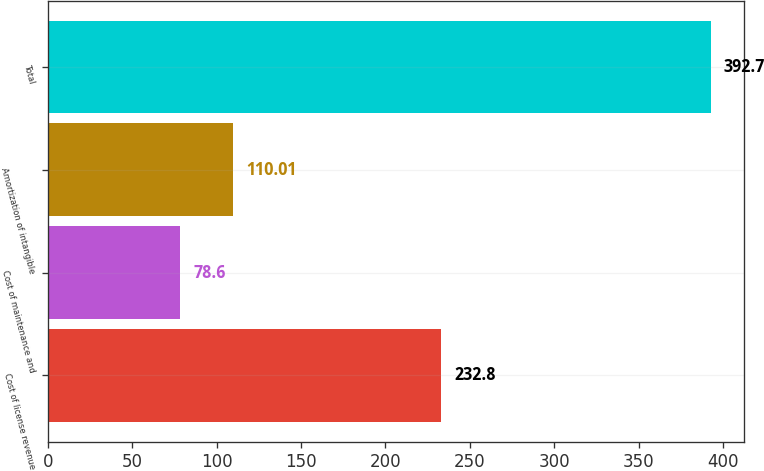<chart> <loc_0><loc_0><loc_500><loc_500><bar_chart><fcel>Cost of license revenue<fcel>Cost of maintenance and<fcel>Amortization of intangible<fcel>Total<nl><fcel>232.8<fcel>78.6<fcel>110.01<fcel>392.7<nl></chart> 